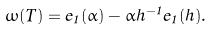<formula> <loc_0><loc_0><loc_500><loc_500>\omega ( T ) = e _ { 1 } ( \alpha ) - \alpha h ^ { - 1 } e _ { 1 } ( h ) .</formula> 